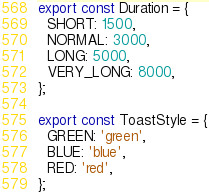<code> <loc_0><loc_0><loc_500><loc_500><_JavaScript_>export const Duration = {
  SHORT: 1500,
  NORMAL: 3000,
  LONG: 5000,
  VERY_LONG: 8000,
};

export const ToastStyle = {
  GREEN: 'green',
  BLUE: 'blue',
  RED: 'red',
};
</code> 